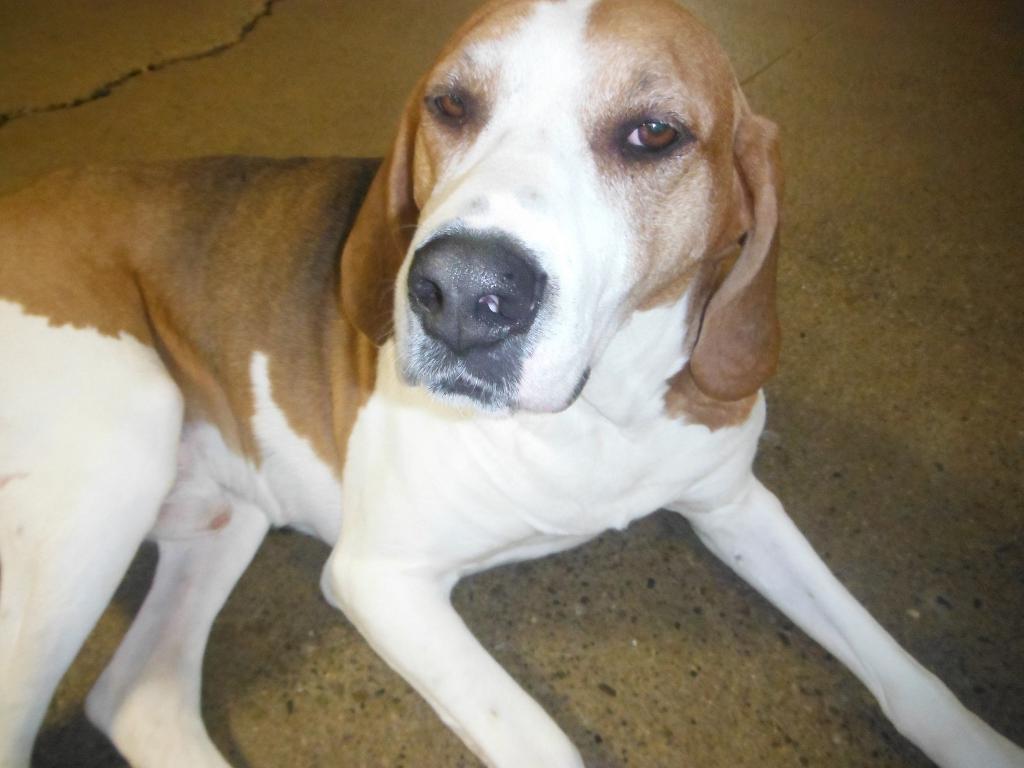In one or two sentences, can you explain what this image depicts? In the picture I can see a dog which is in brown and white color is on the floor. 